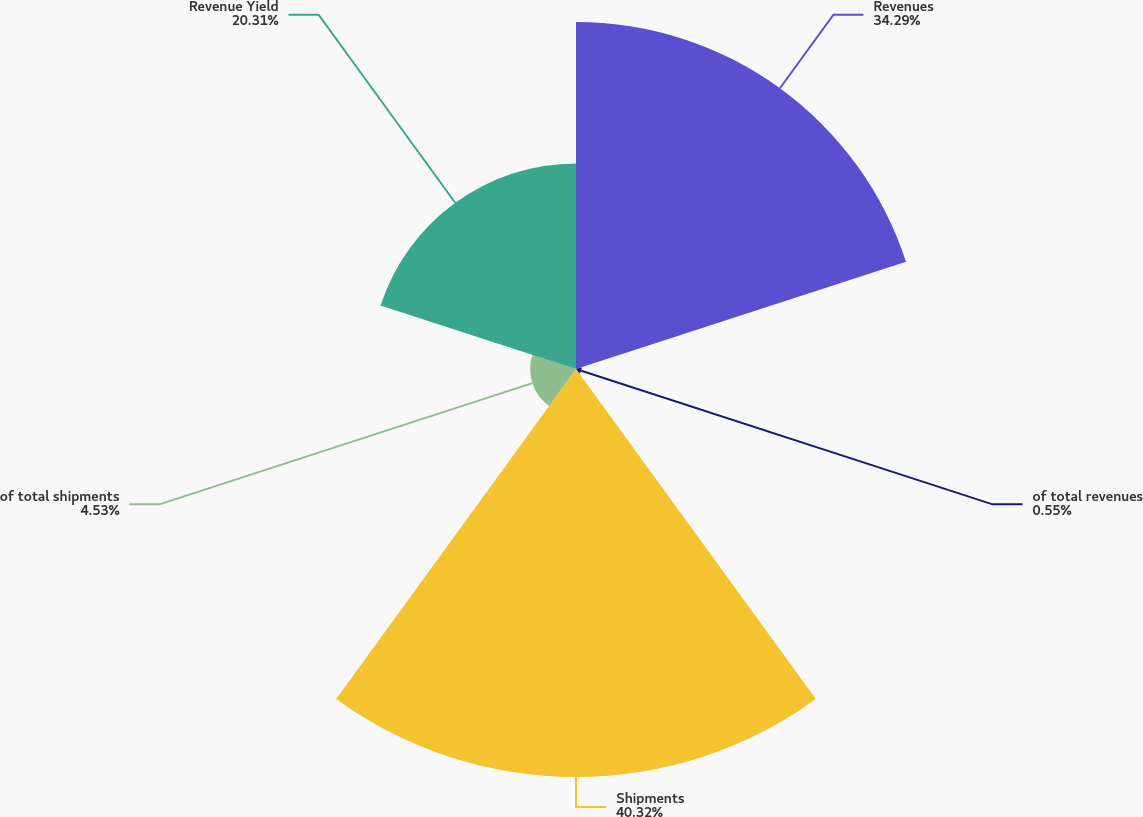<chart> <loc_0><loc_0><loc_500><loc_500><pie_chart><fcel>Revenues<fcel>of total revenues<fcel>Shipments<fcel>of total shipments<fcel>Revenue Yield<nl><fcel>34.29%<fcel>0.55%<fcel>40.32%<fcel>4.53%<fcel>20.31%<nl></chart> 